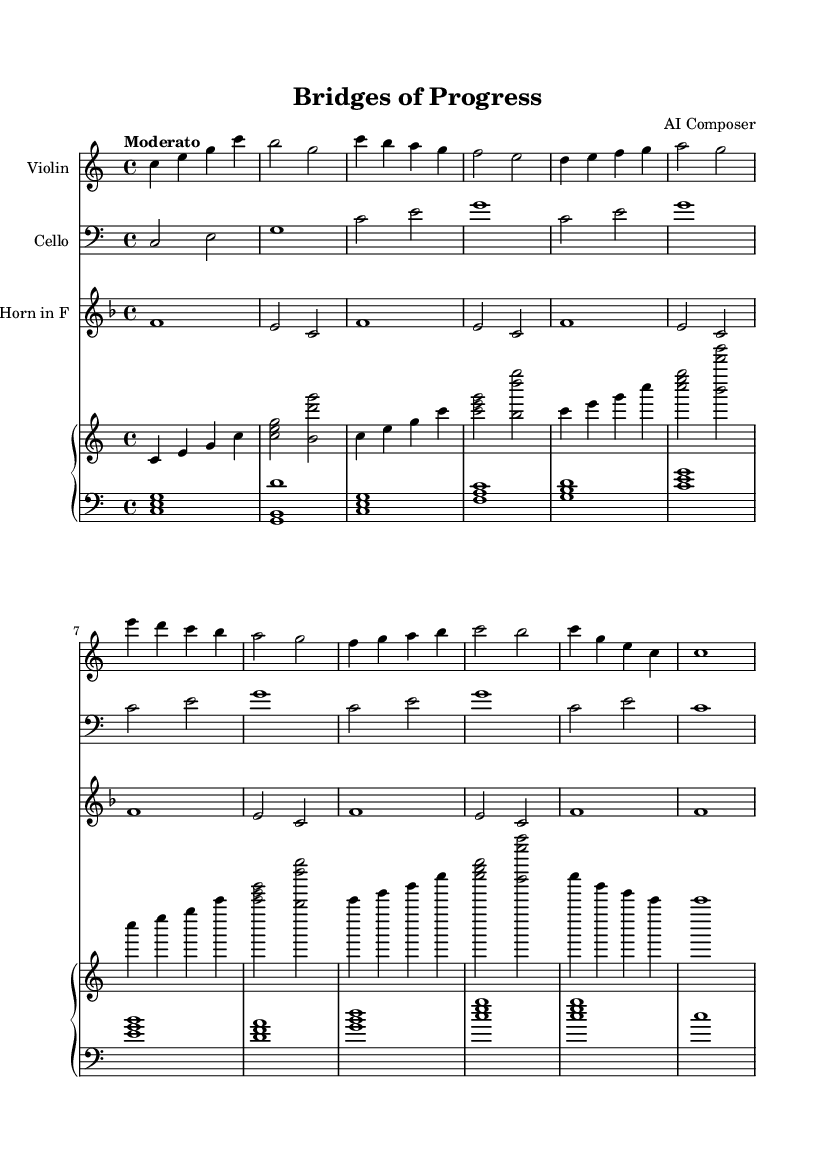What is the key signature of this music? The key signature is C major, which has no sharps or flats.
Answer: C major What is the time signature of the piece? The time signature is indicated at the beginning of the staff and is 4/4, meaning there are four beats in a measure and a quarter note gets one beat.
Answer: 4/4 What is the tempo marking for the composition? The tempo marking is "Moderato," which suggests a moderate speed for the piece, typically considered to be a moderate pace in music.
Answer: Moderato How many instruments are in the score? By counting the individual staves, we can see that there are four instruments represented: violin, cello, horn in F, and piano.
Answer: Four What is the first note played by the violin? The first note of the violin part is a middle C, which is notated as c in the score.
Answer: C Which instrument has the lowest written pitch? The lowest pitch is written for the cello, which uses the bass clef and generally plays in a lower range than the other instruments.
Answer: Cello What is the last note of the horn part? The last note in the horn part is also a C, which is indicated by the final notation of the staff.
Answer: C 